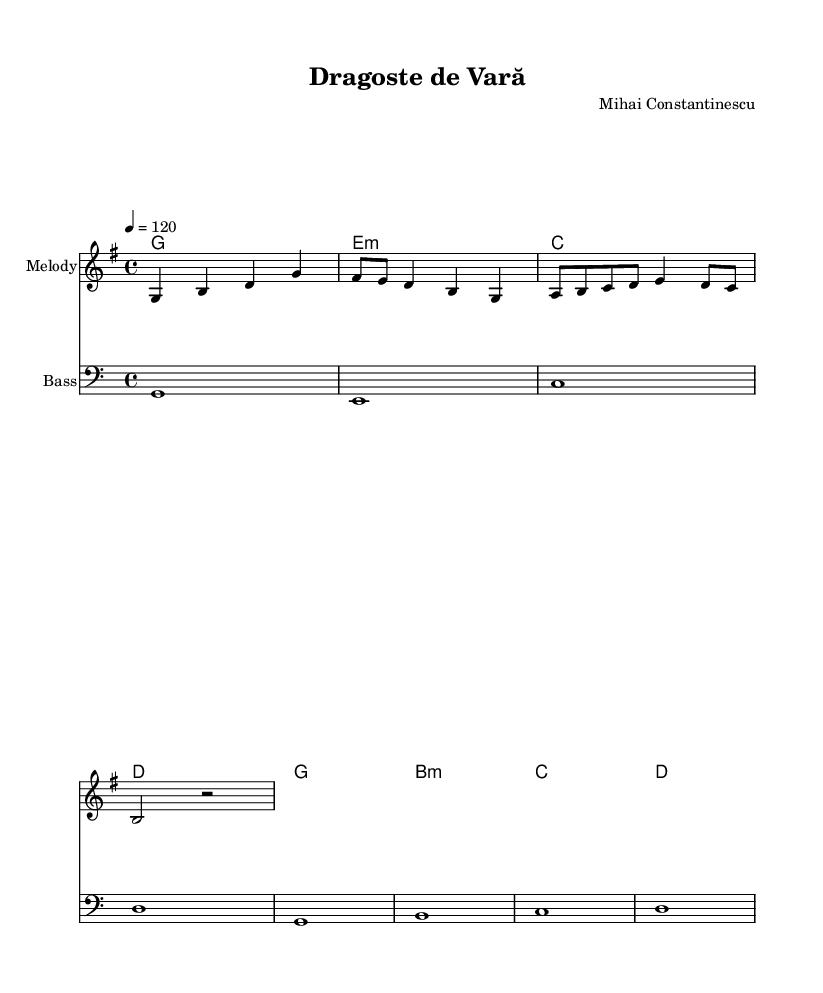What is the key signature of this music? The key signature is G major, which has one sharp (F#). This is determined by looking for sharps or flats at the beginning of the staff, where the sharp is indicated.
Answer: G major What is the time signature of the piece? The time signature is 4/4, which means there are four beats per measure, and the quarter note gets one beat. This is indicated at the beginning of the piece next to the key signature.
Answer: 4/4 What is the tempo marking for this music? The tempo marking is a quarter note equals 120 beats per minute. This indicates how fast the piece should be played and is shown above the staff.
Answer: 120 What is the first note of the melody? The first note of the melody is G, which can be identified as the first note in the melody line on the staff.
Answer: G How many measures are in the melody section? The melody section contains 8 measures, which can be counted by identifying the vertical lines (bar lines) that separate the measures in the staff.
Answer: 8 What is the last chord in the harmony section? The last chord in the harmony section is D, which is the final chord notated in the chord mode section.
Answer: D What type of instrument is indicated for the melody? The indicated instrument for the melody is the electric piano, as mentioned in the instrument name underneath the staff.
Answer: Electric piano 